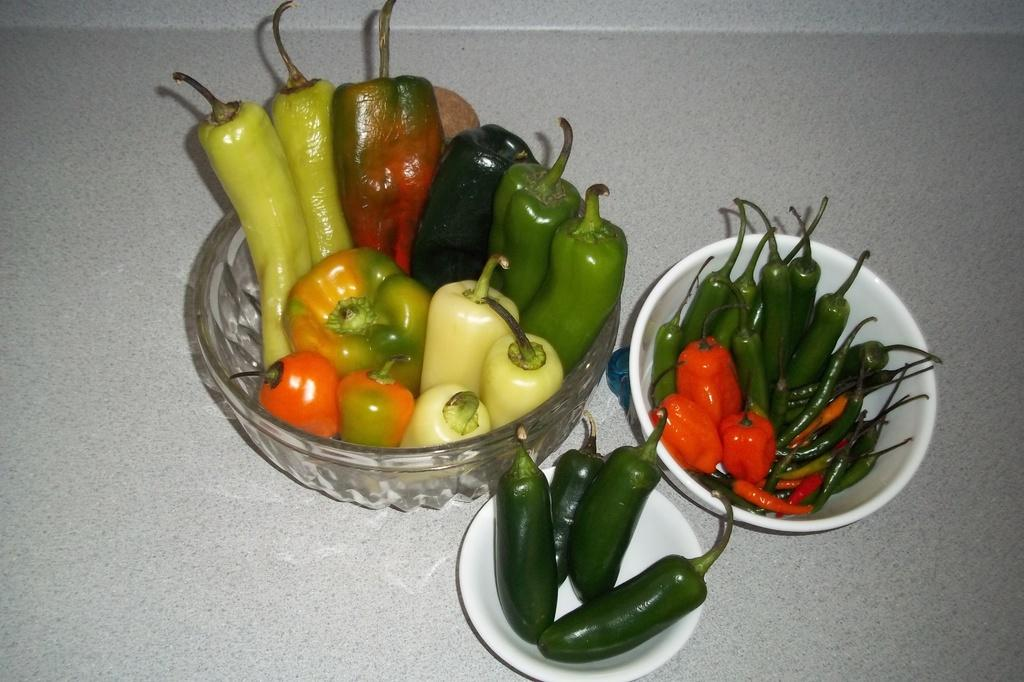What type of vegetables are in the image? There are capsicums and chilies in the image. How are the capsicums and chilies arranged in the image? The capsicums and chilies are in bowls. What is the color of the surface on which the bowls are placed? The bowls are on a white surface. Can you see any oranges in the image? There are no oranges present in the image. Is there a face visible on any of the capsicums or chilies in the image? There is no face visible on any of the capsicums or chilies in the image. 